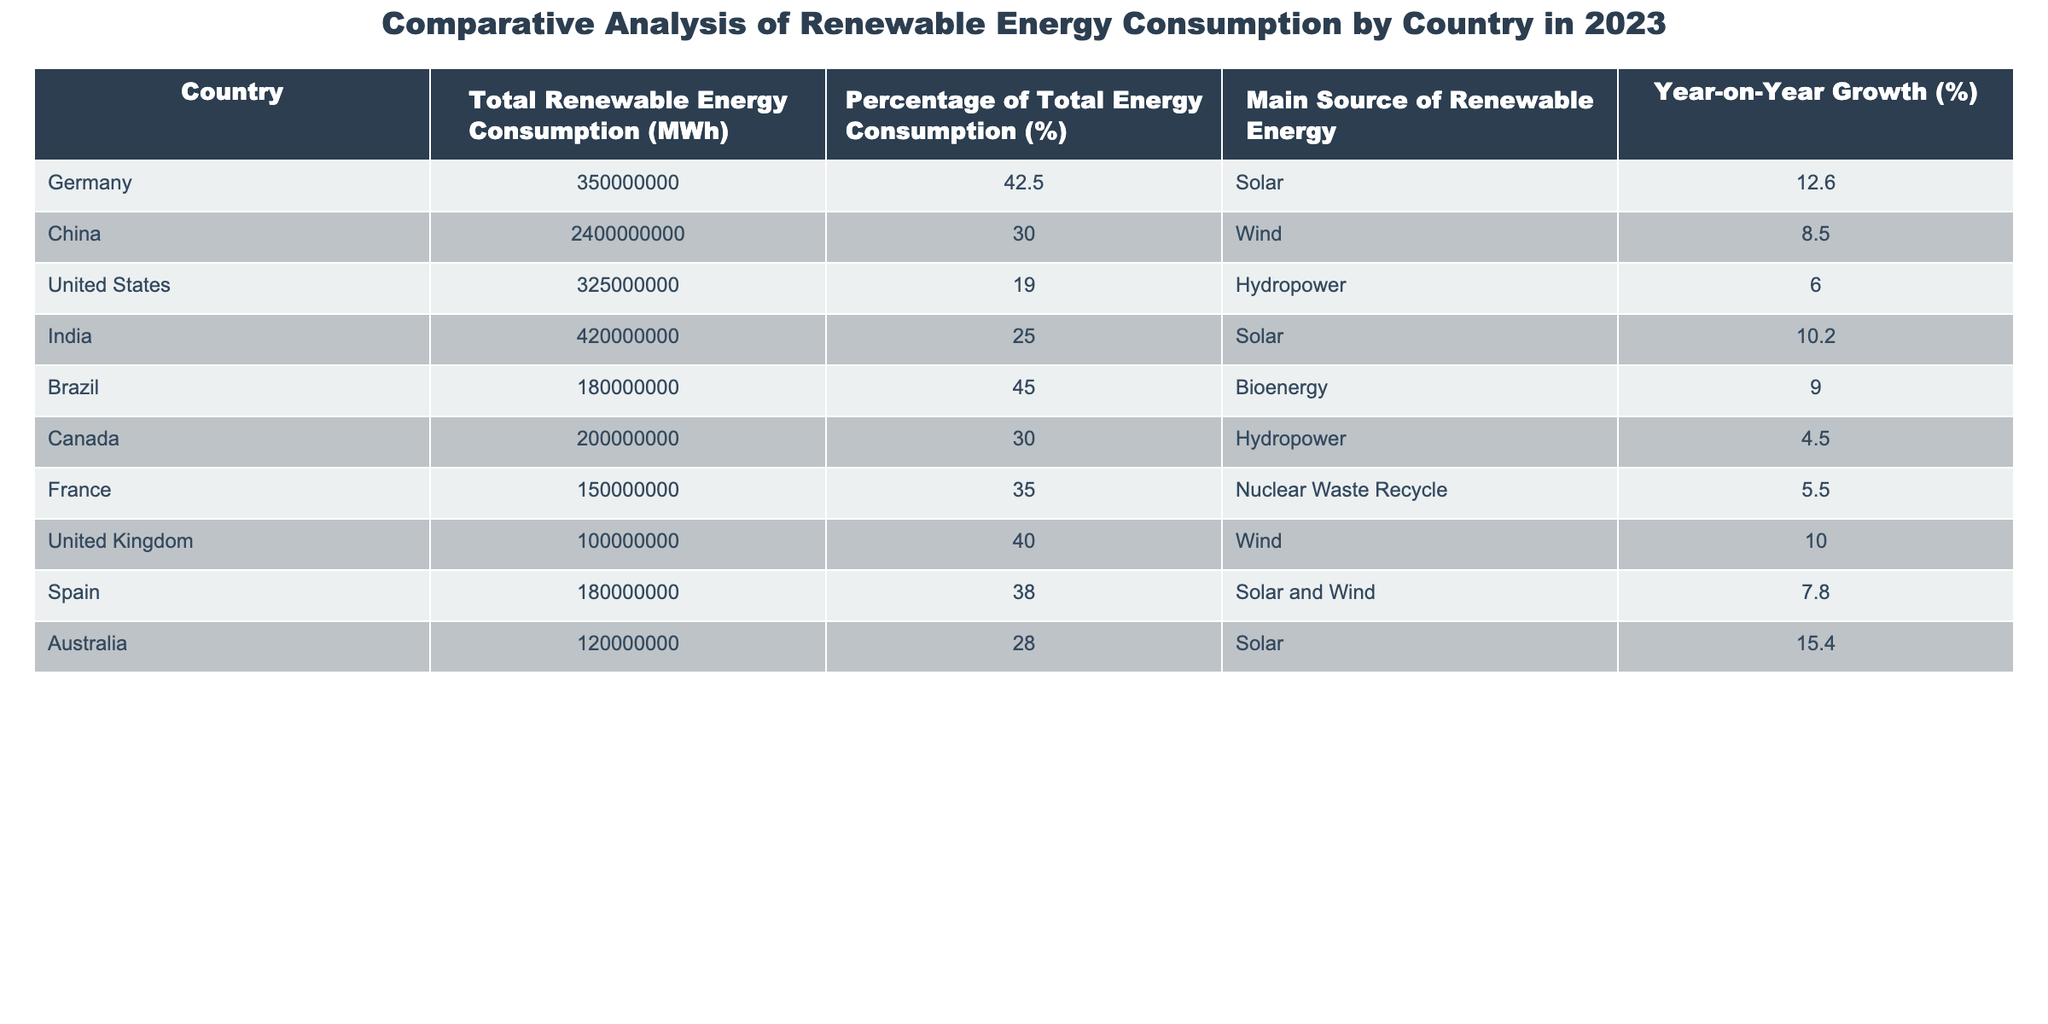What is the total renewable energy consumption in China? According to the table, the total renewable energy consumption for China is listed as 2,400,000,000 MWh.
Answer: 2,400,000,000 MWh Which country has the highest percentage of renewable energy consumption? The table shows that Brazil has the highest percentage of total energy consumption from renewable sources at 45%.
Answer: 45% What are the main renewable energy sources in Germany and India? Looking at the table, Germany's main source of renewable energy is Solar, while India's main source is also Solar.
Answer: Solar (for both) Is the year-on-year growth rate for renewable energy consumption higher in Australia or Canada? In Australia, the year-on-year growth rate is 15.4%, while in Canada it is 4.5%. Since 15.4% is greater than 4.5%, Australia has a higher growth rate.
Answer: Australia What is the difference in total renewable energy consumption between the United States and Brazil? The total renewable energy consumption for Brazil is 180,000,000 MWh and for the United States, it is 325,000,000 MWh. The difference is 325,000,000 - 180,000,000 = 145,000,000 MWh.
Answer: 145,000,000 MWh Which country has the lowest total renewable energy consumption? By examining the table, Canada has the lowest total renewable energy consumption at 200,000,000 MWh.
Answer: 200,000,000 MWh Is the percentage of renewable energy consumption in France higher than that in the United States? France has a percentage of 35%, while the United States has 19%. Since 35% is greater than 19%, the statement is true.
Answer: Yes What is the average year-on-year growth rate for the countries listed? To find the average, add all the year-on-year growth rates: (12.6 + 8.5 + 6 + 10.2 + 9 + 4.5 + 5.5 + 10 + 7.8 + 15.4) = 79.5%. There are 10 countries, so the average growth rate is 79.5/10 = 7.95%.
Answer: 7.95% Which two countries have more than 40% of their total energy consumption coming from renewables? The table shows Brazil (45%) and Germany (42.5%) both have more than 40% of their total energy consumption from renewable energy.
Answer: Brazil and Germany 